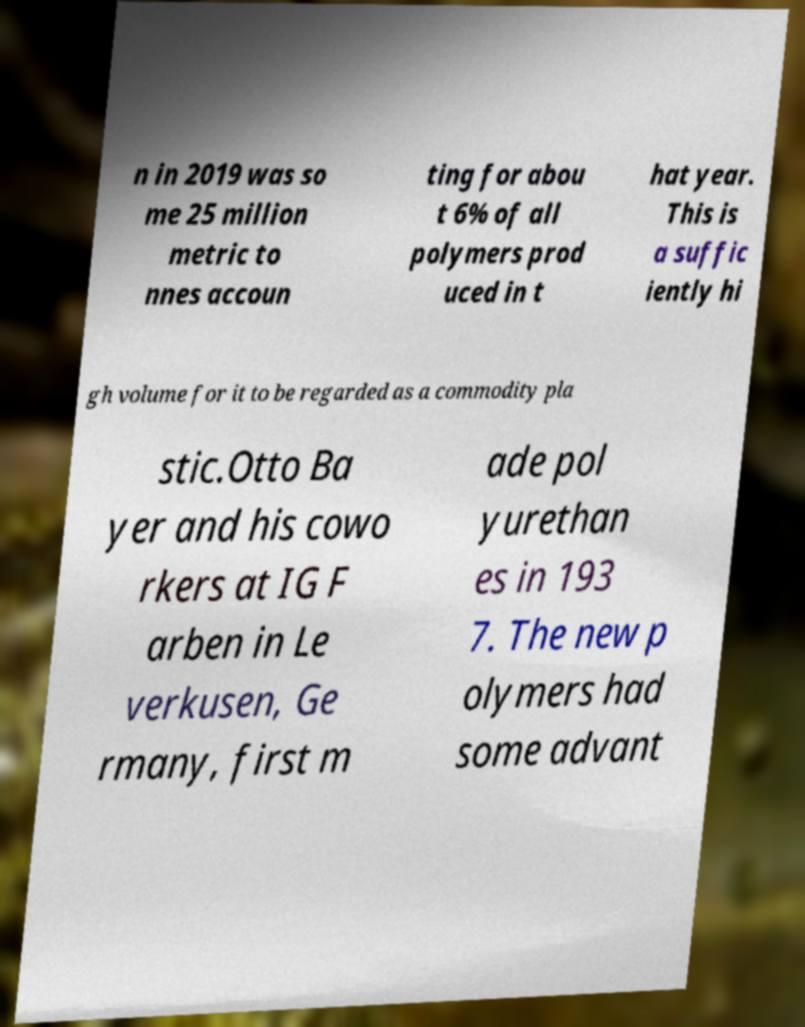What messages or text are displayed in this image? I need them in a readable, typed format. n in 2019 was so me 25 million metric to nnes accoun ting for abou t 6% of all polymers prod uced in t hat year. This is a suffic iently hi gh volume for it to be regarded as a commodity pla stic.Otto Ba yer and his cowo rkers at IG F arben in Le verkusen, Ge rmany, first m ade pol yurethan es in 193 7. The new p olymers had some advant 